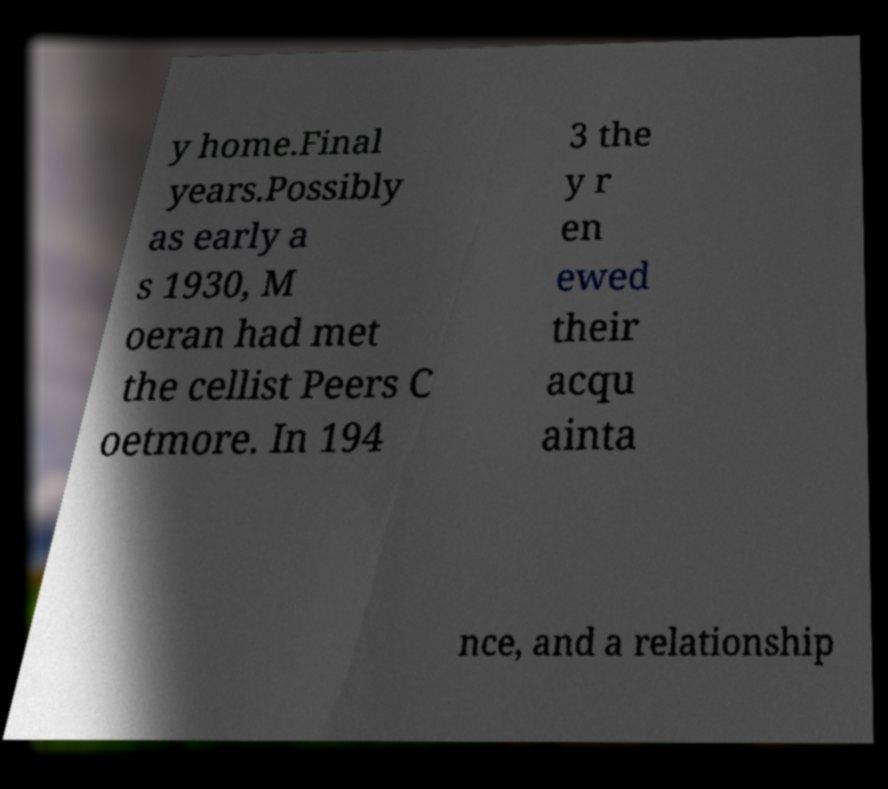Please identify and transcribe the text found in this image. y home.Final years.Possibly as early a s 1930, M oeran had met the cellist Peers C oetmore. In 194 3 the y r en ewed their acqu ainta nce, and a relationship 